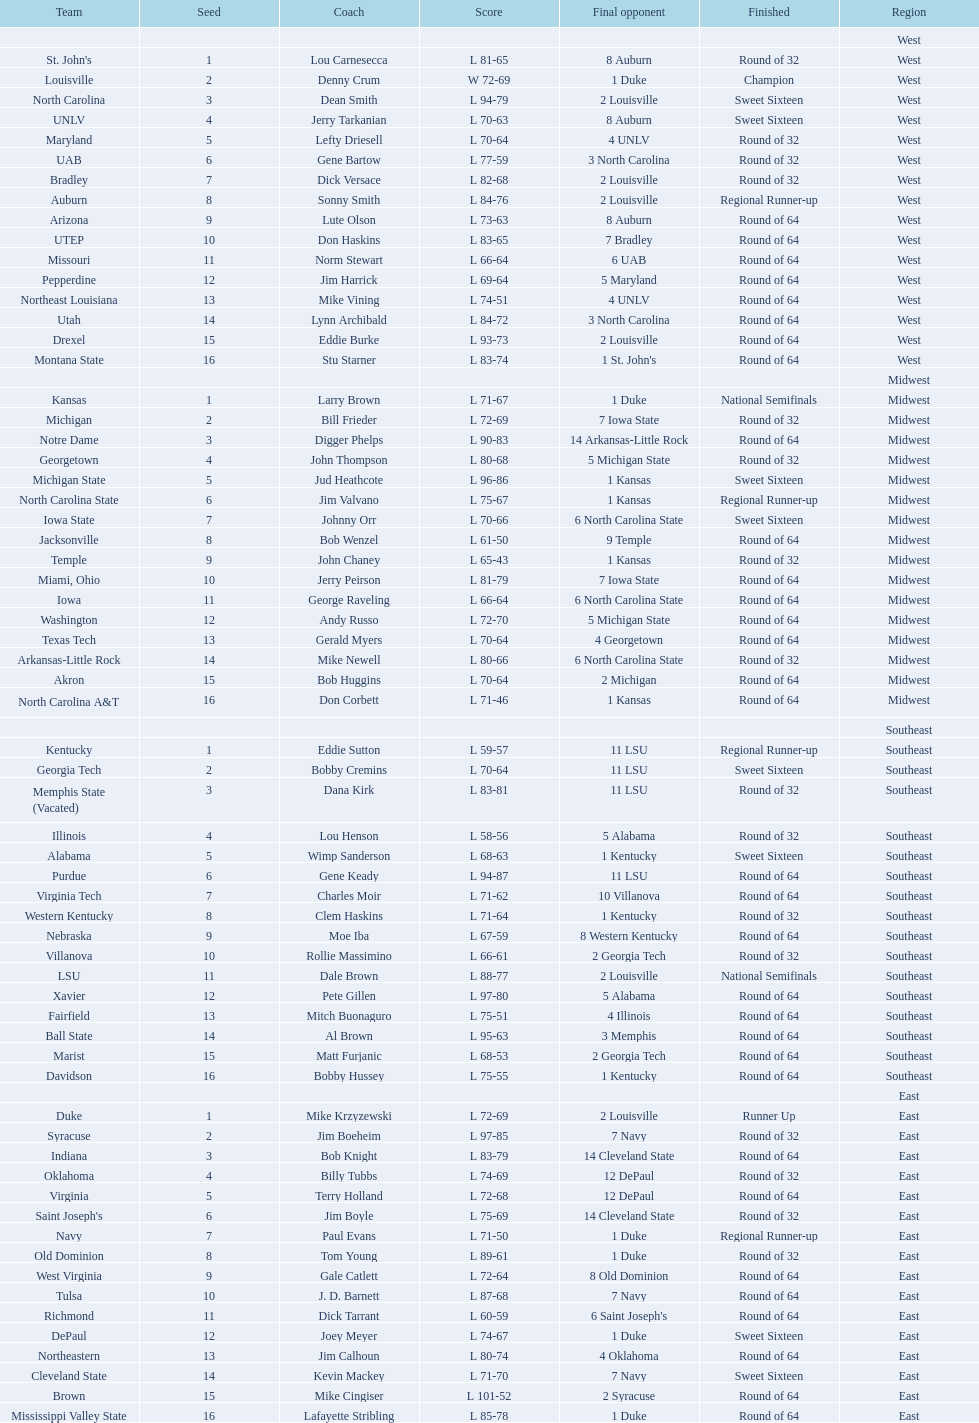North carolina and unlv each made it to which round? Sweet Sixteen. 